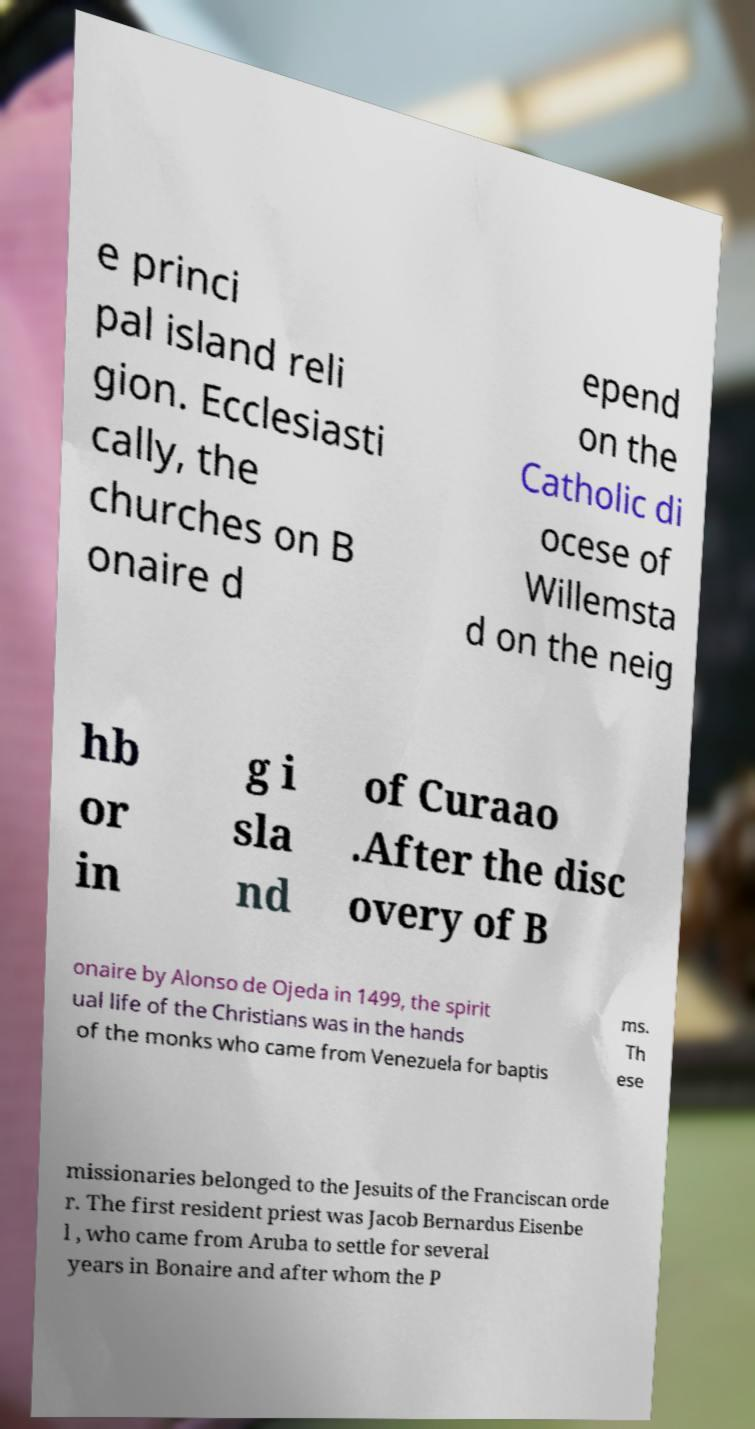Could you extract and type out the text from this image? e princi pal island reli gion. Ecclesiasti cally, the churches on B onaire d epend on the Catholic di ocese of Willemsta d on the neig hb or in g i sla nd of Curaao .After the disc overy of B onaire by Alonso de Ojeda in 1499, the spirit ual life of the Christians was in the hands of the monks who came from Venezuela for baptis ms. Th ese missionaries belonged to the Jesuits of the Franciscan orde r. The first resident priest was Jacob Bernardus Eisenbe l , who came from Aruba to settle for several years in Bonaire and after whom the P 